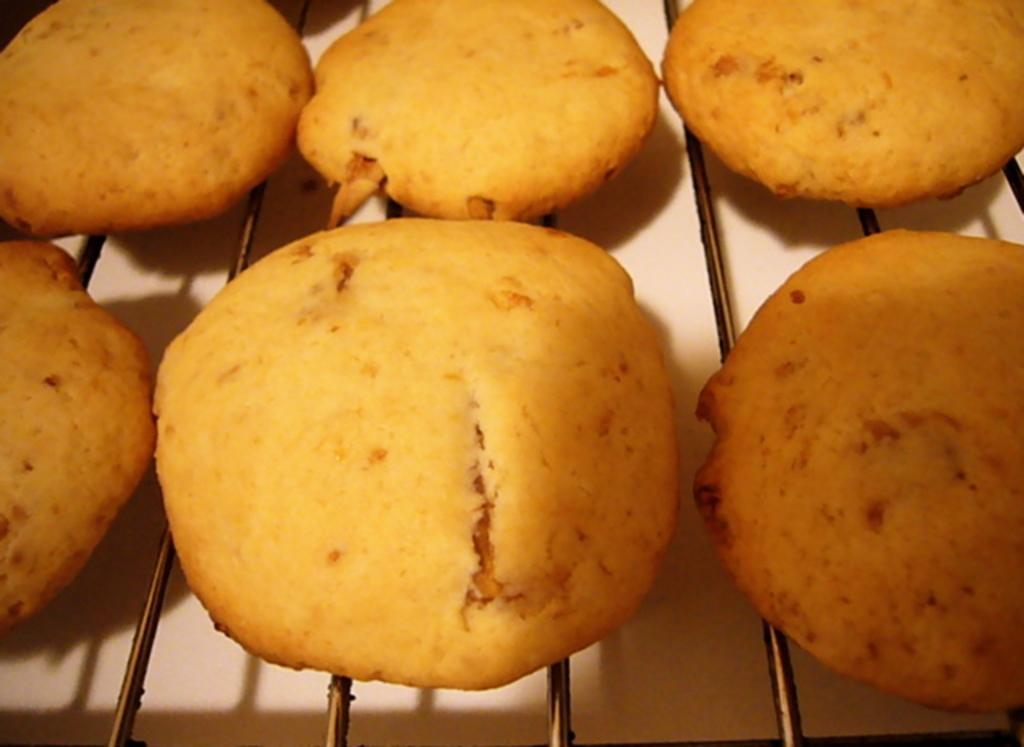In one or two sentences, can you explain what this image depicts? In this picture we can see cookies on the grill and the grill on the white surface. 